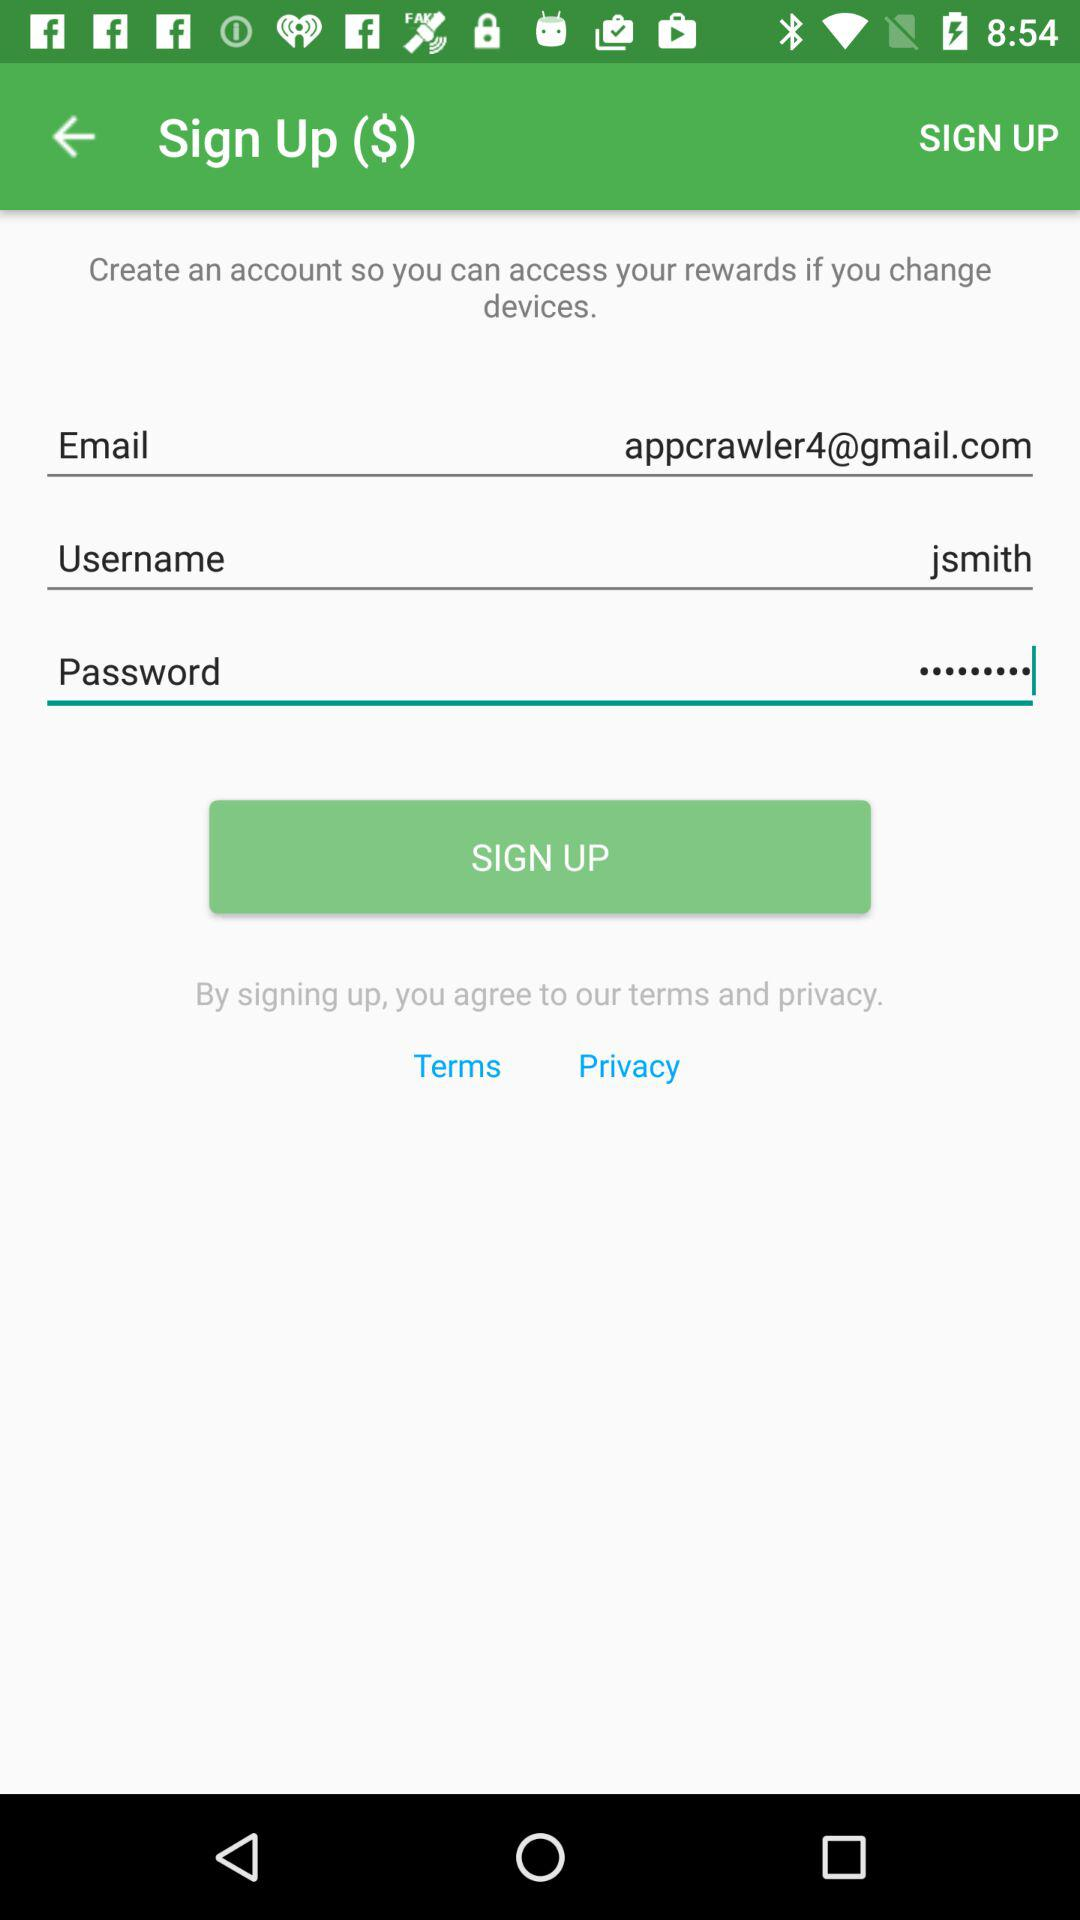What is the user name? The user name is "jsmith". 